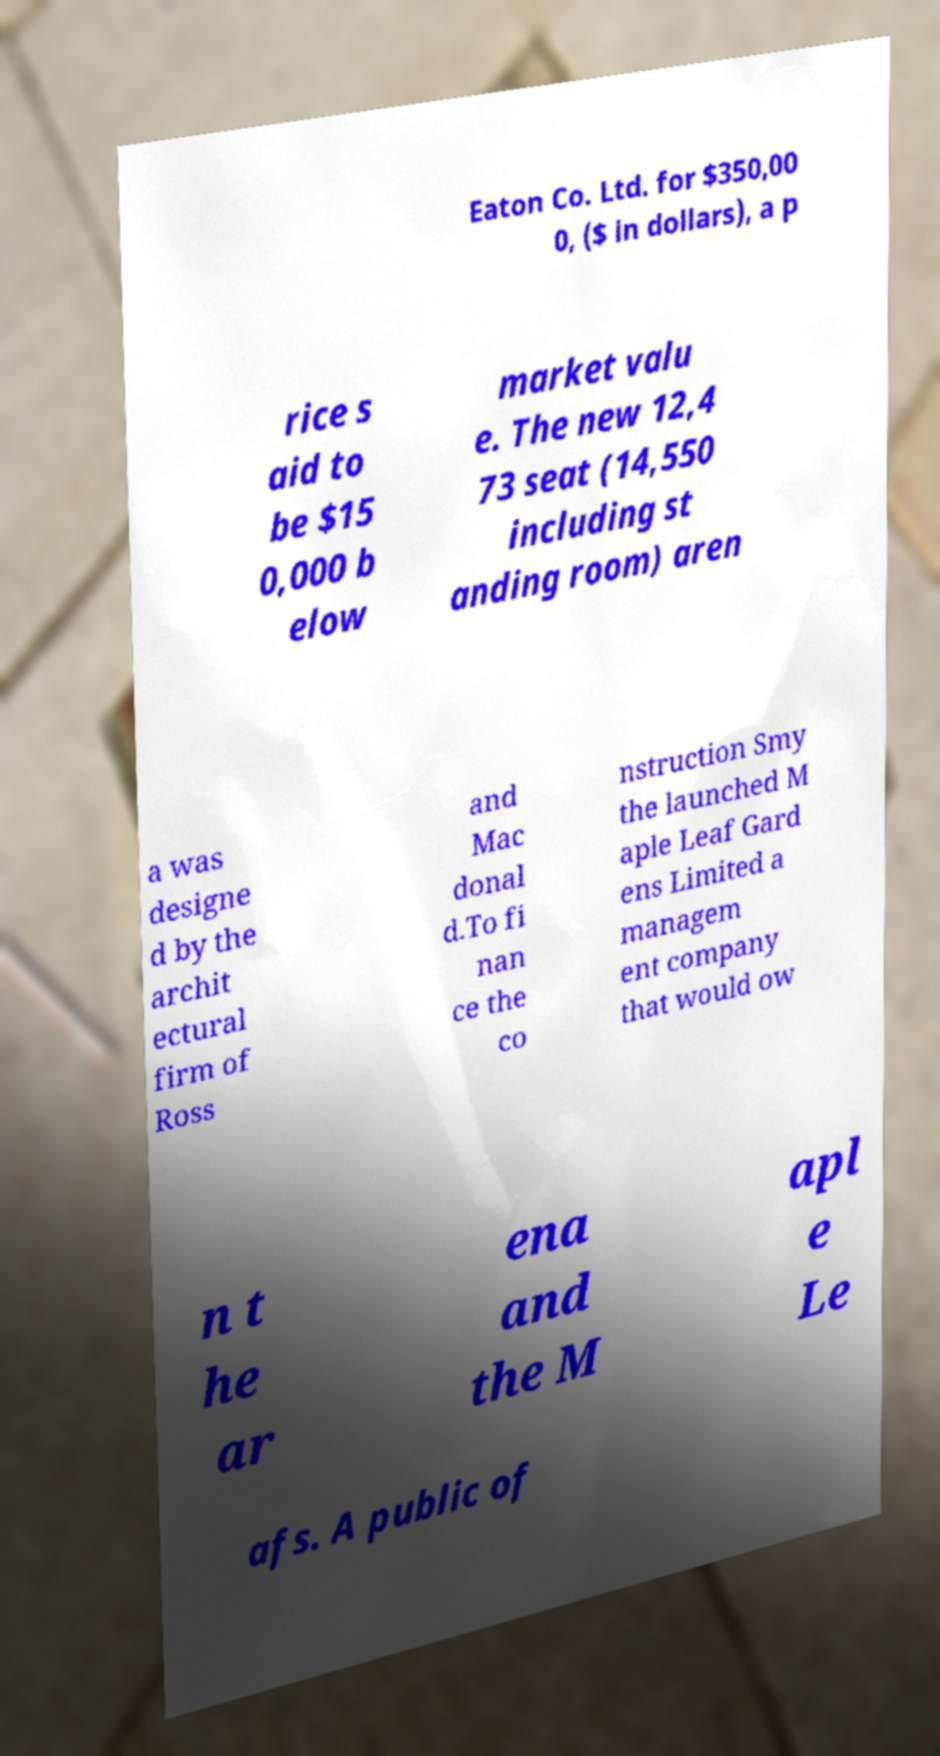There's text embedded in this image that I need extracted. Can you transcribe it verbatim? Eaton Co. Ltd. for $350,00 0, ($ in dollars), a p rice s aid to be $15 0,000 b elow market valu e. The new 12,4 73 seat (14,550 including st anding room) aren a was designe d by the archit ectural firm of Ross and Mac donal d.To fi nan ce the co nstruction Smy the launched M aple Leaf Gard ens Limited a managem ent company that would ow n t he ar ena and the M apl e Le afs. A public of 